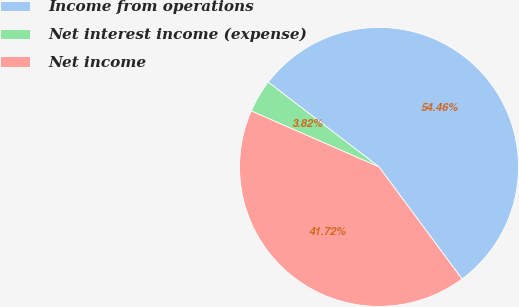Convert chart to OTSL. <chart><loc_0><loc_0><loc_500><loc_500><pie_chart><fcel>Income from operations<fcel>Net interest income (expense)<fcel>Net income<nl><fcel>54.46%<fcel>3.82%<fcel>41.72%<nl></chart> 